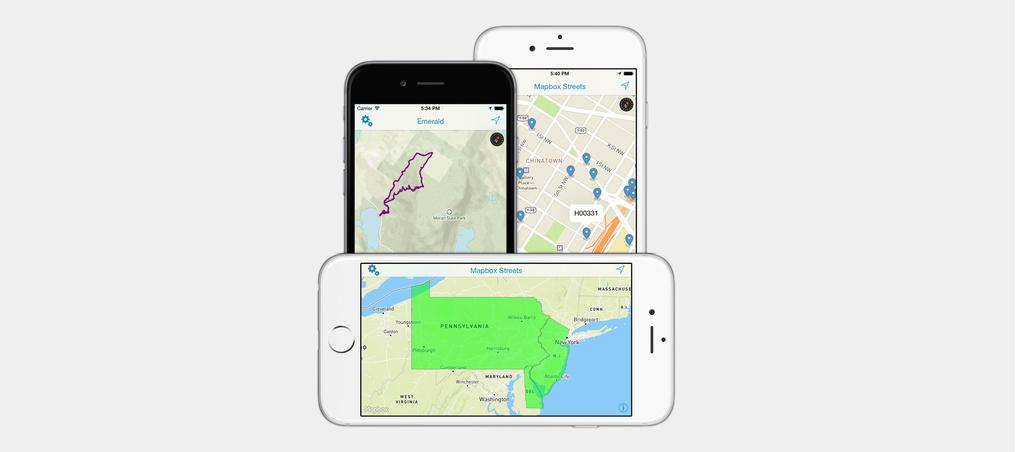<image>
Provide a brief description of the given image. a phone with mapbox streets written on it 